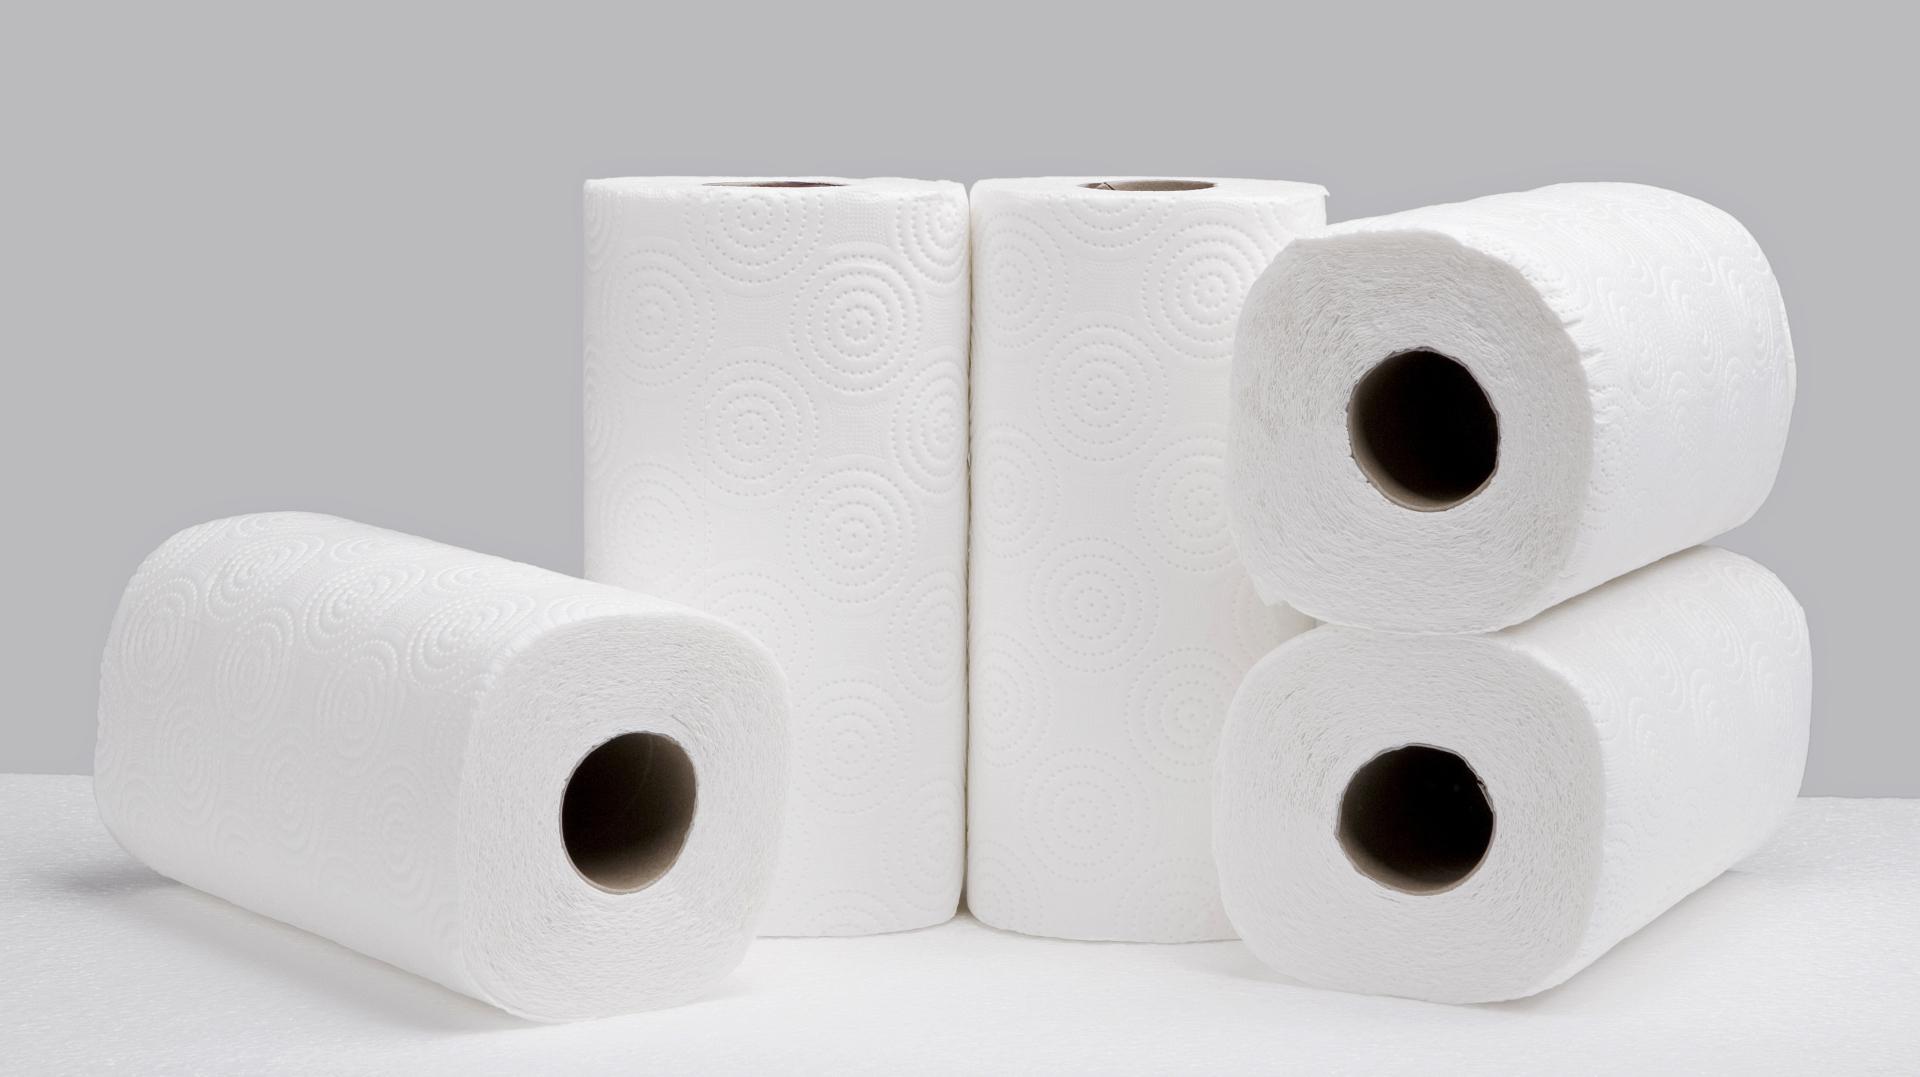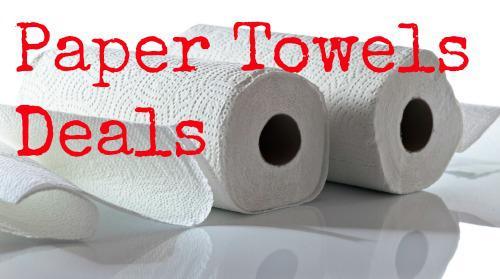The first image is the image on the left, the second image is the image on the right. Examine the images to the left and right. Is the description "Two paper towel rolls lie on a surface in one of the images." accurate? Answer yes or no. Yes. The first image is the image on the left, the second image is the image on the right. Analyze the images presented: Is the assertion "An image features some neatly stacked rolls of paper towels." valid? Answer yes or no. Yes. 